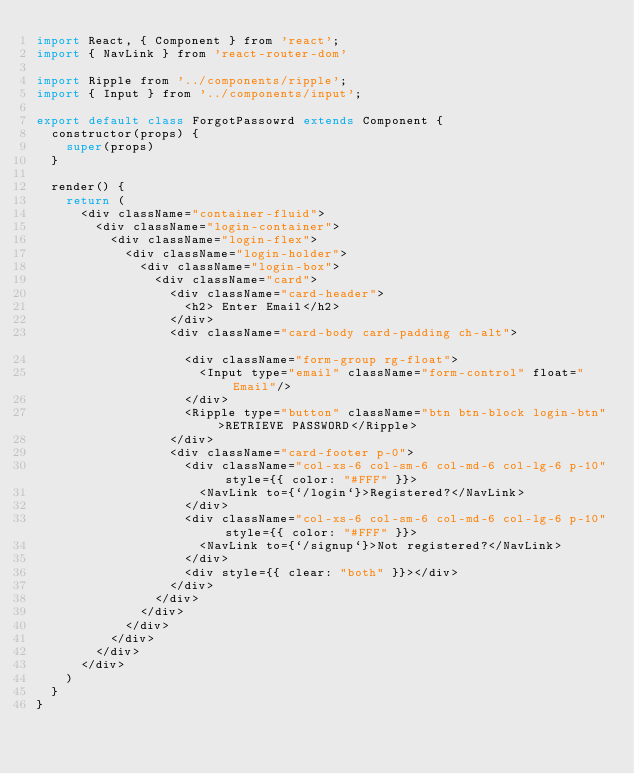Convert code to text. <code><loc_0><loc_0><loc_500><loc_500><_JavaScript_>import React, { Component } from 'react';
import { NavLink } from 'react-router-dom'

import Ripple from '../components/ripple';
import { Input } from '../components/input';

export default class ForgotPassowrd extends Component {
	constructor(props) {
		super(props)
	}

	render() {
		return (
			<div className="container-fluid">
				<div className="login-container">
					<div className="login-flex">
						<div className="login-holder">
							<div className="login-box">
								<div className="card">
									<div className="card-header">
										<h2> Enter Email</h2>
									</div>
									<div className="card-body card-padding ch-alt">																			
										<div className="form-group rg-float">
											<Input type="email" className="form-control" float="Email"/>
										</div>
										<Ripple type="button" className="btn btn-block login-btn">RETRIEVE PASSWORD</Ripple>
									</div>
									<div className="card-footer p-0">
										<div className="col-xs-6 col-sm-6 col-md-6 col-lg-6 p-10" style={{ color: "#FFF" }}>
											<NavLink to={`/login`}>Registered?</NavLink>
										</div>
										<div className="col-xs-6 col-sm-6 col-md-6 col-lg-6 p-10" style={{ color: "#FFF" }}>
											<NavLink to={`/signup`}>Not registered?</NavLink>
										</div>
										<div style={{ clear: "both" }}></div>
									</div>
								</div>
							</div>
						</div>
					</div>
				</div>
			</div>
		)
	}
}</code> 